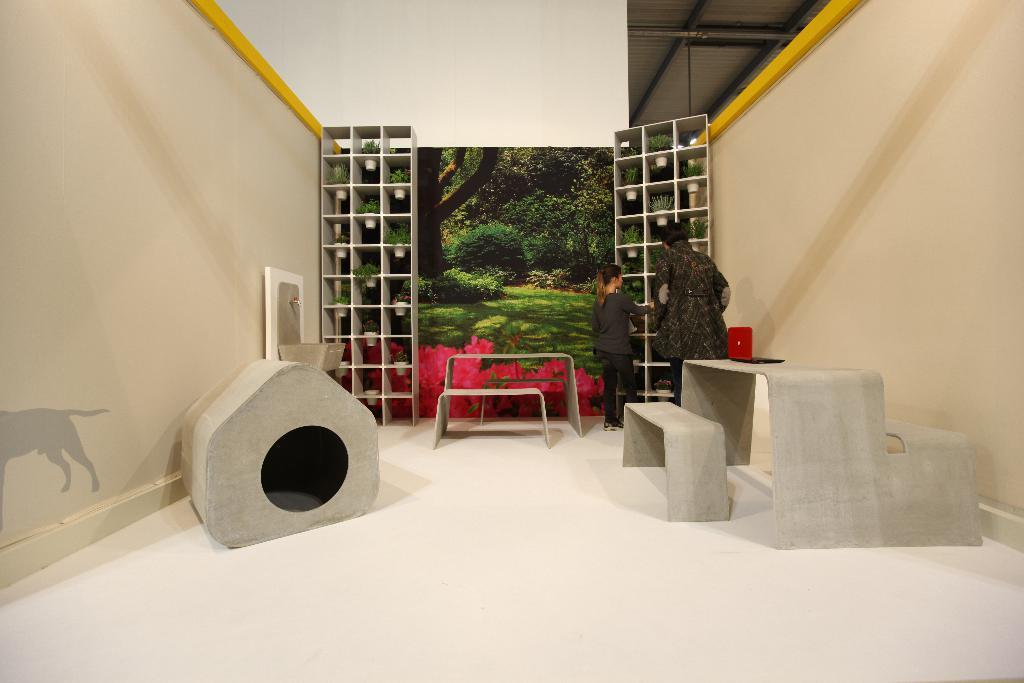Can you describe this image briefly? In this image, we can see few objects on the white surface. Here there is a laptop. Background we can see house plants, few people and objects. On the left side of the image, we can see an animal picture on the wall. Top of the image, we can see rods. 